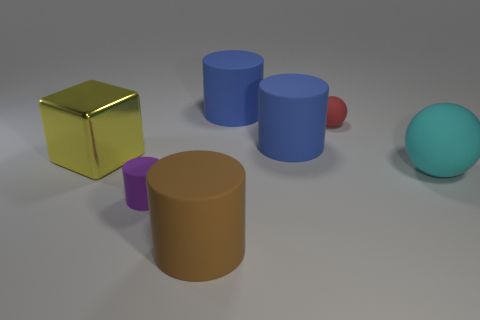Is the number of blue cylinders behind the tiny ball the same as the number of purple rubber cylinders that are behind the large metallic block?
Keep it short and to the point. No. Are there any blue matte cylinders of the same size as the yellow shiny object?
Offer a terse response. Yes. The brown cylinder is what size?
Keep it short and to the point. Large. Are there an equal number of cylinders to the left of the metallic block and small purple matte blocks?
Offer a very short reply. Yes. There is a rubber object that is in front of the large ball and behind the brown rubber cylinder; what color is it?
Your answer should be very brief. Purple. What is the size of the matte cylinder that is behind the blue cylinder in front of the cylinder behind the red matte thing?
Offer a very short reply. Large. What number of things are tiny objects that are behind the yellow metal object or rubber objects that are behind the big rubber sphere?
Your answer should be very brief. 3. What is the shape of the large shiny thing?
Provide a short and direct response. Cube. How many other things are the same material as the large brown cylinder?
Provide a short and direct response. 5. What is the size of the purple matte object that is the same shape as the brown matte object?
Your response must be concise. Small. 